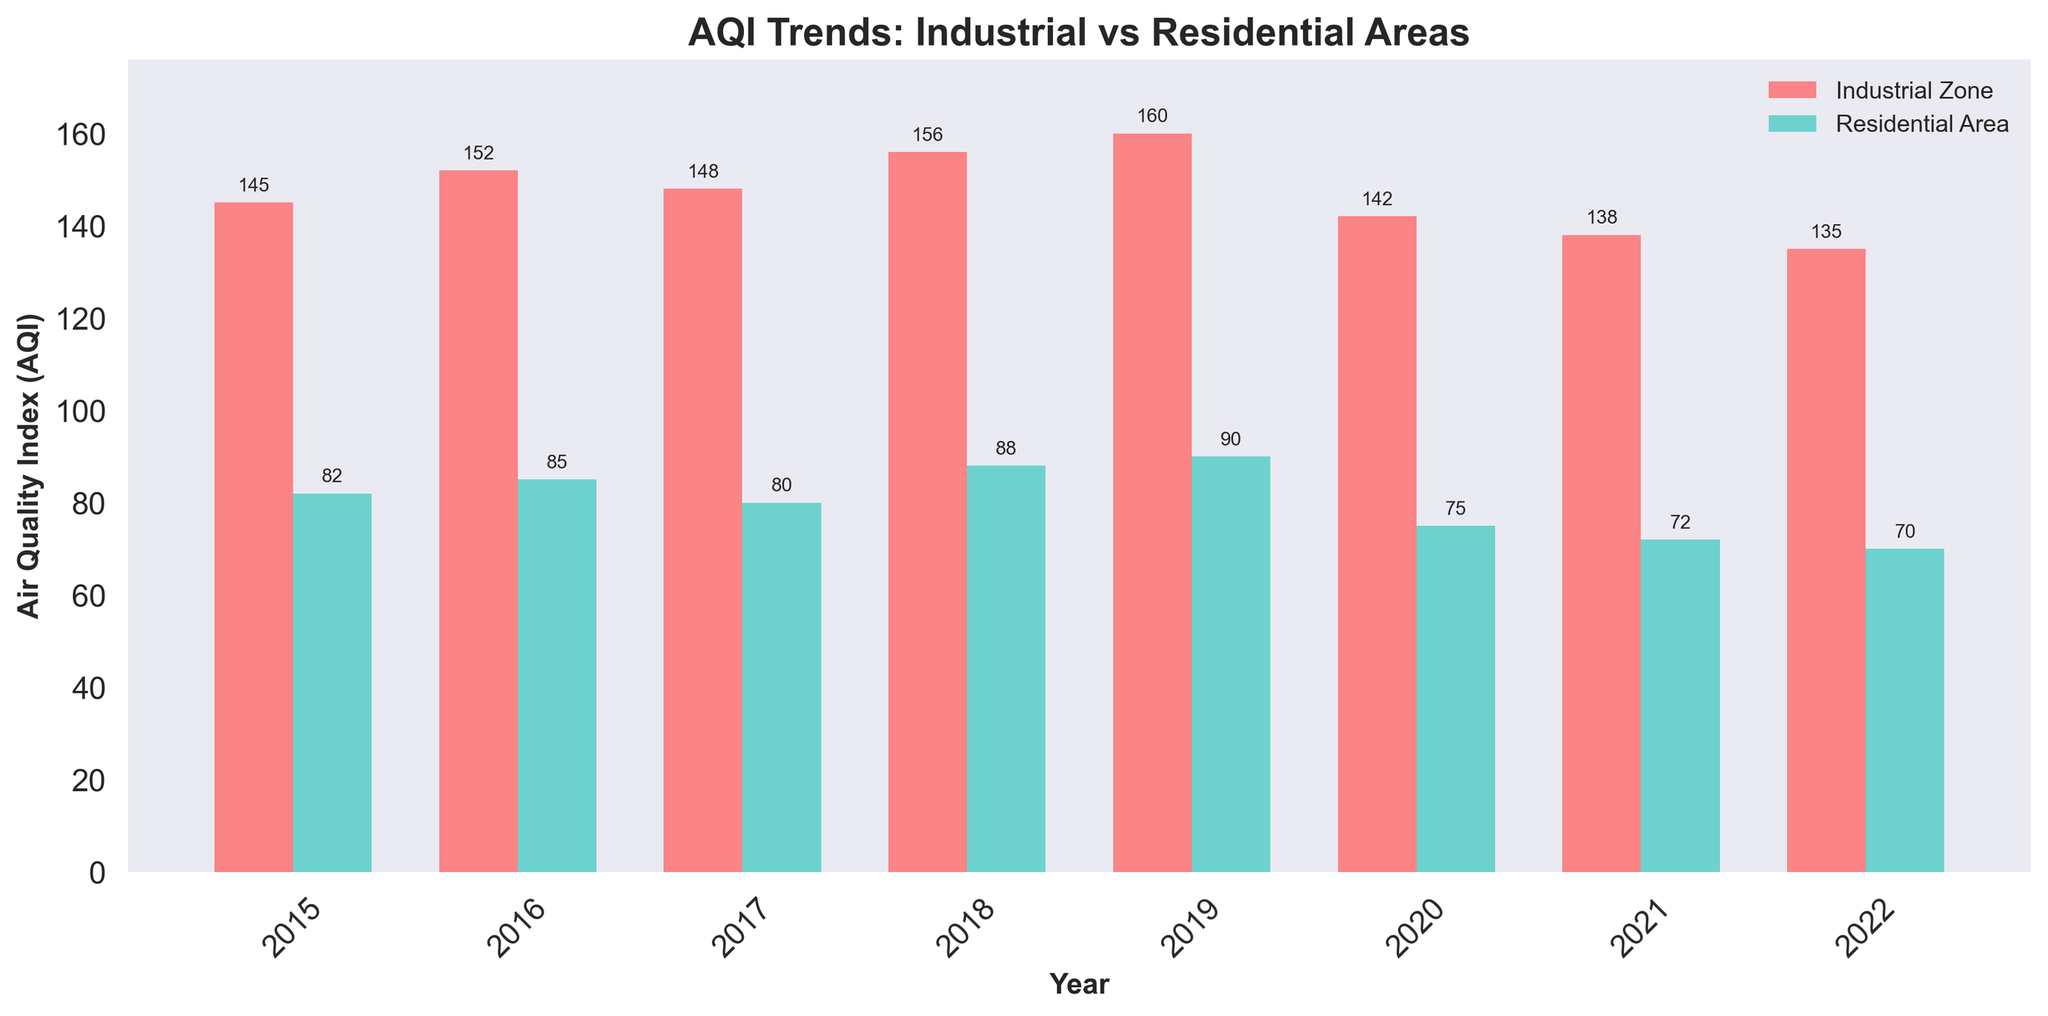What's the average AQI in the Industrial Zone for the years 2015-2022? The AQI values for the Industrial Zone over the years 2015-2022 are 145, 152, 148, 156, 160, 142, 138, and 135. Adding these gives a sum of 1176. The number of years is 8, so the average AQI is 1176/8 = 147
Answer: 147 What is the difference in AQI between the Industrial Zone and the Residential Area in 2019? The AQI for the Industrial Zone in 2019 is 160, while for the Residential Area it is 90. The difference is 160 - 90 = 70
Answer: 70 How did the AQI in the Residential Area change from 2020 to 2021? The AQI in the Residential Area decreased from 75 in 2020 to 72 in 2021. The change is 75 - 72 = 3 units
Answer: Decreased by 3 units Which year had the highest AQI in the Industrial Zone, and what was the value? By looking at the bar heights for the Industrial Zone, the year 2019 had the highest AQI with a value of 160
Answer: 2019, 160 On average, is the AQI higher in the Industrial Zone or the Residential Area from 2015 to 2022? To determine this, we calculate the average AQI for both zones. The average AQI for the Industrial Zone is 147, while for the Residential Area, summing the values (82, 85, 80, 88, 90, 75, 72, 70) gives 642. Dividing by the number of years, 642/8 = 80.25. The average AQI is higher in the Industrial Zone
Answer: Industrial Zone How many times did the AQI in the Industrial Zone exceed 150? Looking at the values from the chart, AQIs in the Industrial Zone exceeded 150 in the years 2016, 2018, and 2019, totaling 3 times
Answer: 3 times Which year shows the largest decrease in AQI in the Industrial Zone, and what was the decrease? The largest decrease appears between 2019 (160) and 2020 (142). The decrease is 160 - 142 = 18 units
Answer: 2019 to 2020, 18 units Compare the AQI trends from 2020 to 2022 for both zones. From 2020 to 2022, the Industrial Zone AQI decreased from 142 to 135, while the Residential Area AQI decreased from 75 to 70. Both zones show a decreasing trend
Answer: Both zones show a decreasing trend By how much did the AQI in the Residential Area increase from 2015 to 2019? The AQI in the Residential Area increased from 82 in 2015 to 90 in 2019, an increase of 90 - 82 = 8 units
Answer: 8 units 